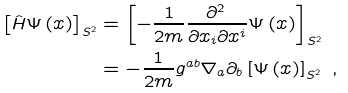<formula> <loc_0><loc_0><loc_500><loc_500>\left [ \hat { H } \Psi \left ( x \right ) \right ] _ { S ^ { 2 } } & = \left [ - \frac { 1 } { 2 m } \frac { \partial ^ { 2 } \, } { \partial x _ { i } \partial x ^ { i } } \Psi \left ( x \right ) \right ] _ { S ^ { 2 } } \\ & = - \frac { 1 } { 2 m } g ^ { a b } \nabla _ { a } \partial _ { b } \left [ \Psi \left ( x \right ) \right ] _ { S ^ { 2 } } \text { ,}</formula> 